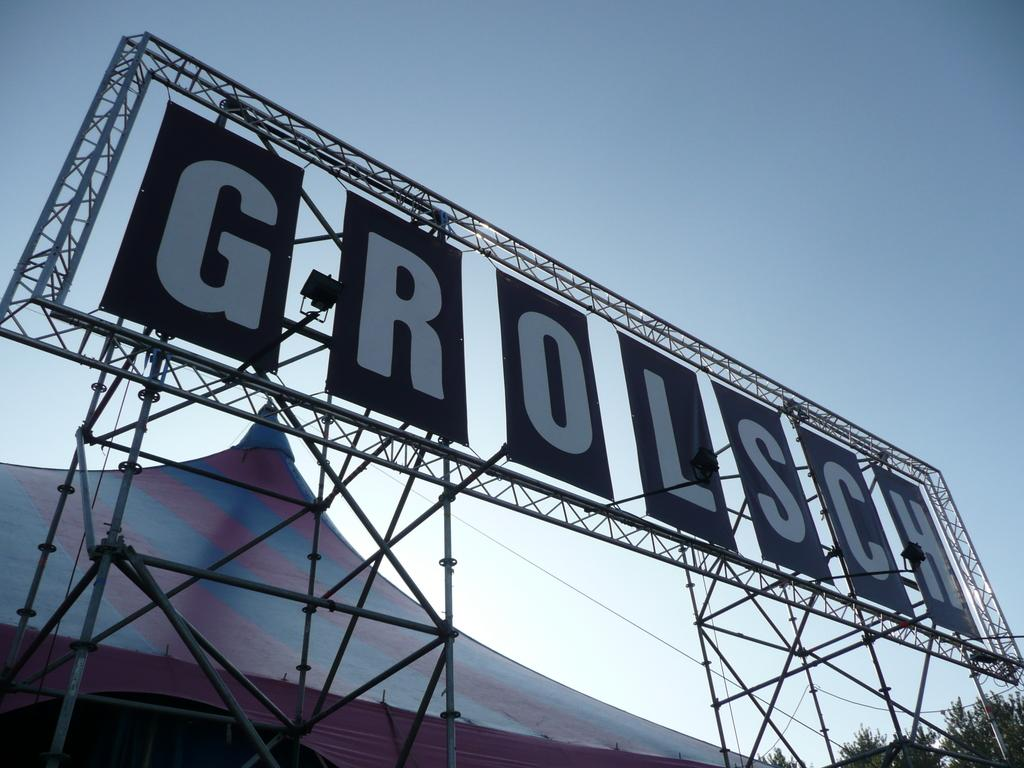<image>
Create a compact narrative representing the image presented. A giant billboard displaying only the name Grolsch. 